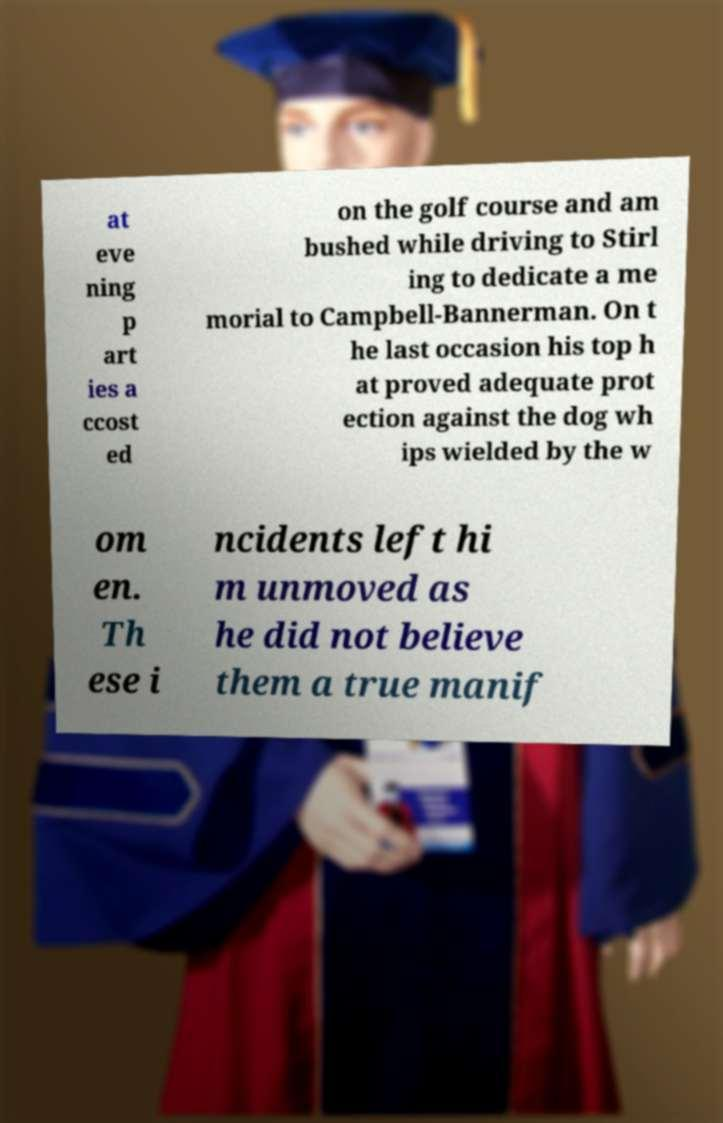There's text embedded in this image that I need extracted. Can you transcribe it verbatim? at eve ning p art ies a ccost ed on the golf course and am bushed while driving to Stirl ing to dedicate a me morial to Campbell-Bannerman. On t he last occasion his top h at proved adequate prot ection against the dog wh ips wielded by the w om en. Th ese i ncidents left hi m unmoved as he did not believe them a true manif 